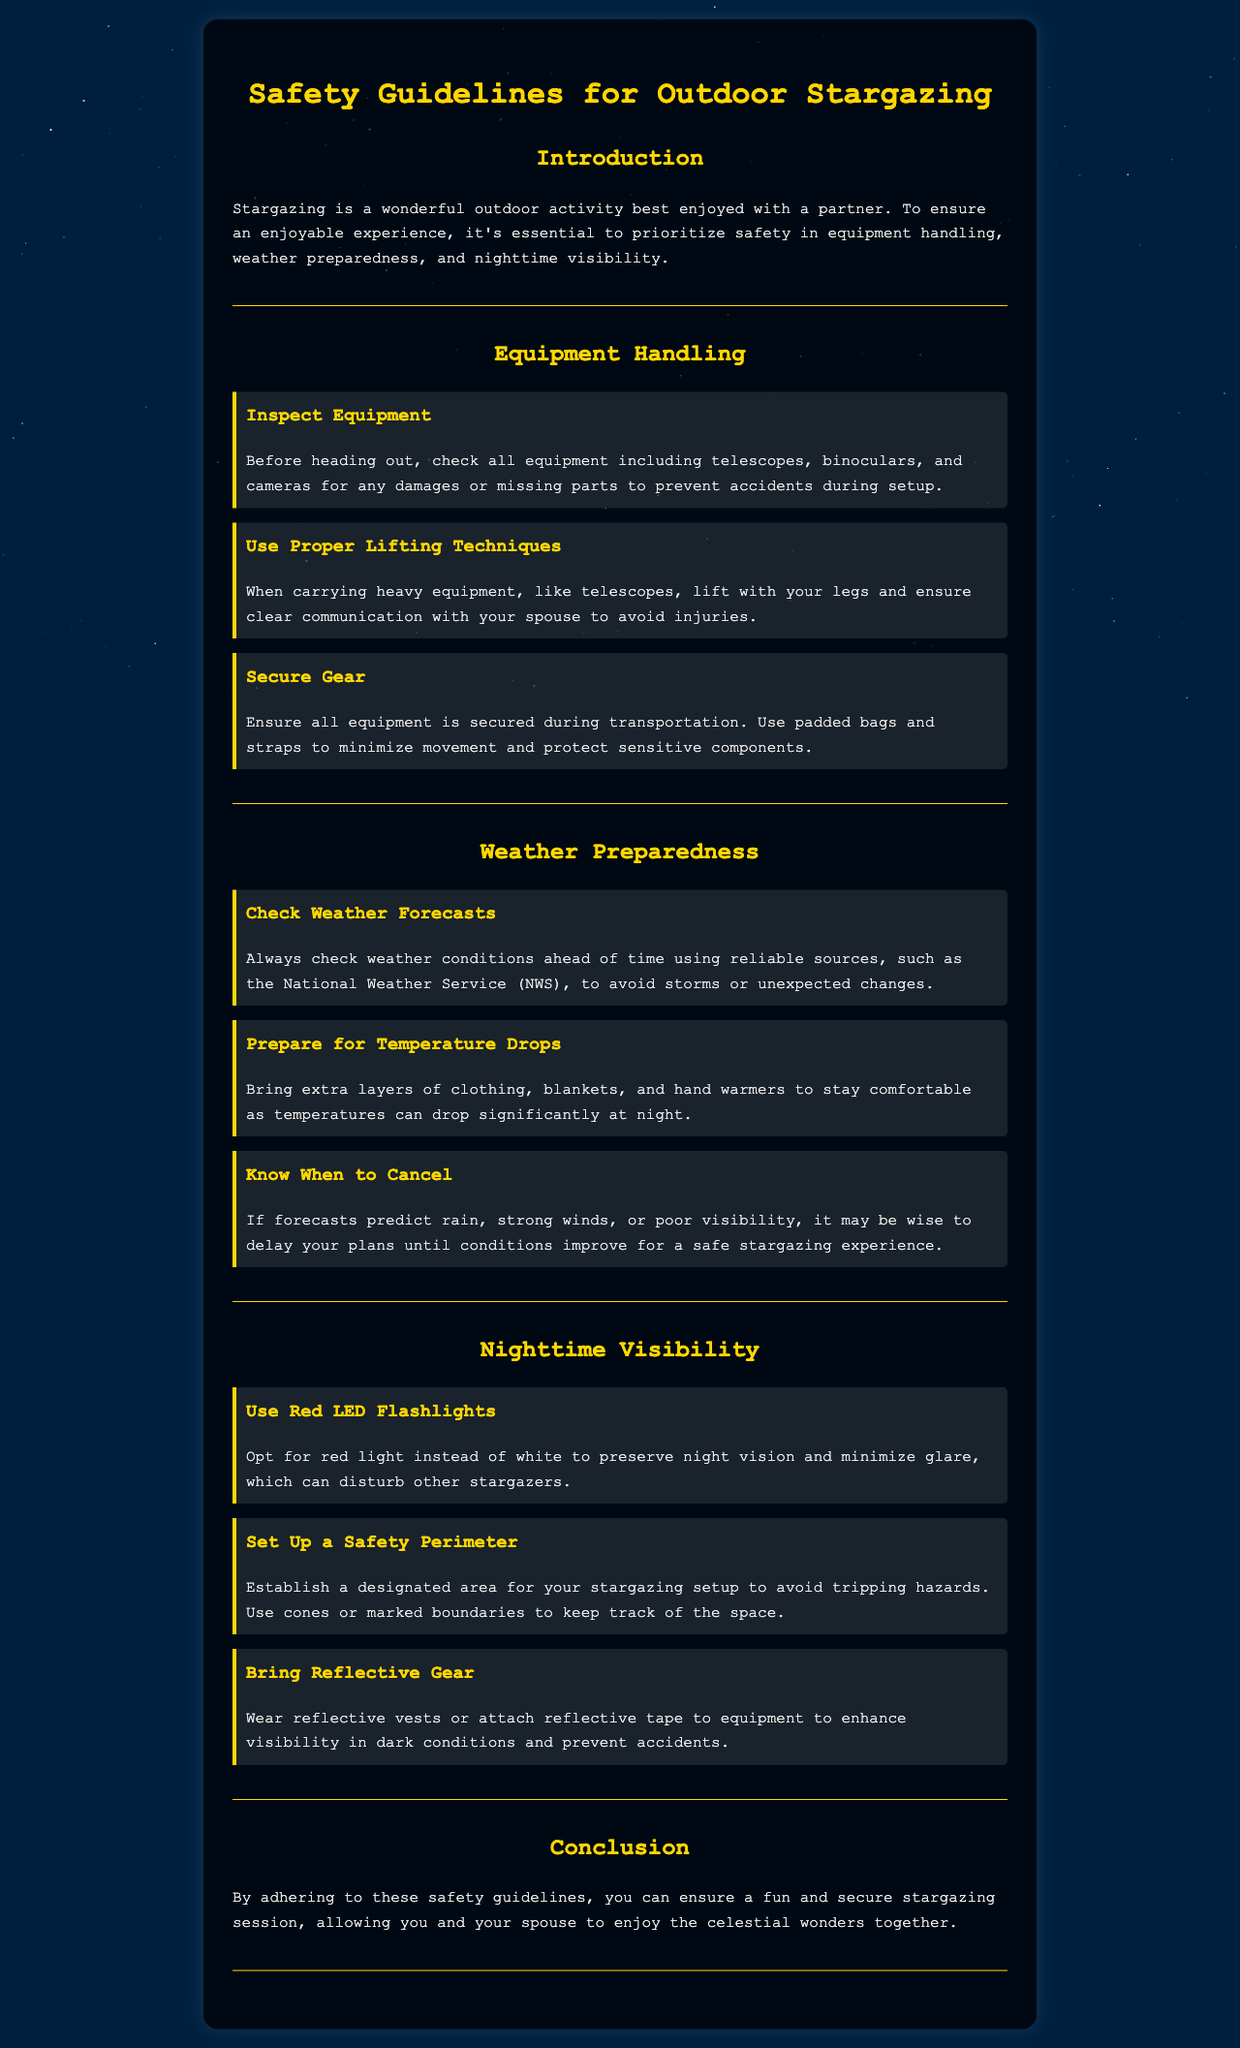What is the title of the document? The title is the main heading presented at the top of the document, which summarizes its focus.
Answer: Safety Guidelines for Outdoor Stargazing How many sections are there in the document? The document is divided into four main sections: Introduction, Equipment Handling, Weather Preparedness, and Nighttime Visibility, with a conclusion at the end.
Answer: Four What should be used for nighttime visibility? This refers to a specific item recommended in the document that helps maintain night vision while stargazing.
Answer: Red LED Flashlights What should be checked before heading out? This involves an inspection procedure mentioned that ensures all necessary equipment is ready and safe for use.
Answer: Equipment What is suggested to bring for temperature drops? This specifies items recommended in the document to ensure comfort during cooler nighttime temperatures.
Answer: Extra layers of clothing What is established to avoid tripping hazards? This indicates a strategy mentioned in the document to enhance safety during stargazing by outlining a defined area.
Answer: Safety Perimeter When should stargazing plans be canceled? This question refers to conditions under which it's wise to postpone stargazing for safety reasons highlighted in the document.
Answer: Rain or strong winds What color light minimizes glare during stargazing? This question pertains to a specific type of light that can help maintain night vision, as suggested in the document.
Answer: Red How should heavy equipment be lifted? This describes the proper technique for handling heavy gear, which is mentioned in the document.
Answer: With your legs 